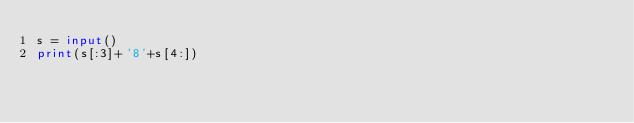<code> <loc_0><loc_0><loc_500><loc_500><_Python_>s = input()
print(s[:3]+'8'+s[4:])</code> 